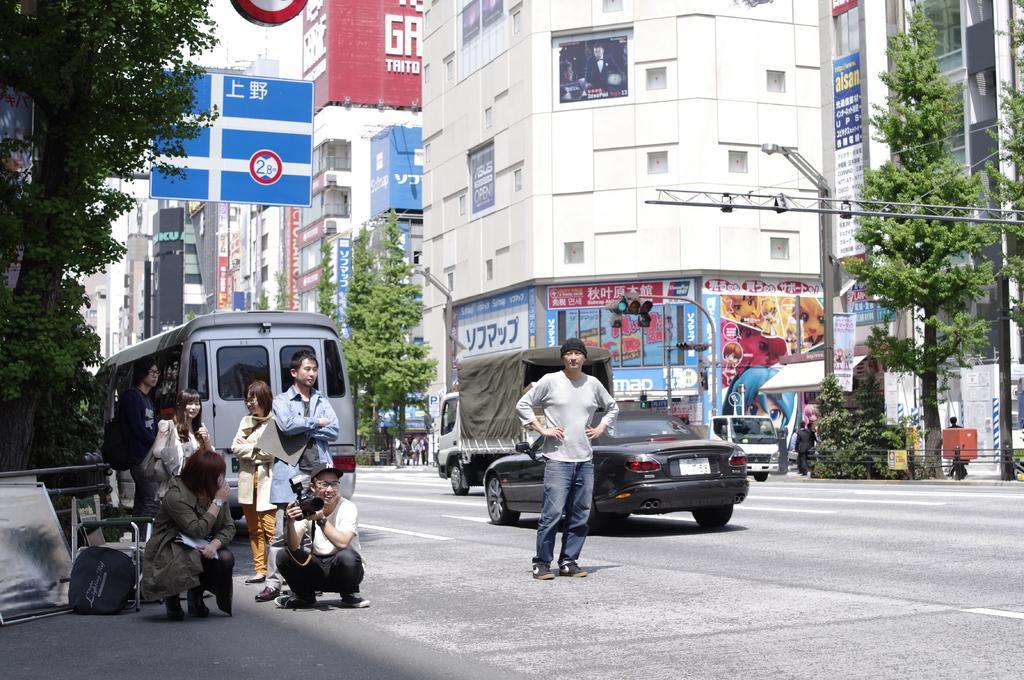How would you summarize this image in a sentence or two? In this picture there is a view of the road and a boy wearing grey color t-shirt with black cap standing on the road and looking into the camera. Beside there is a group of girls and a boy sitting on the road with camera. In the background we can see a big buildings, Street poles, blue caution board and some trees. 